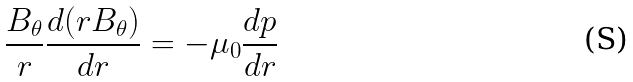Convert formula to latex. <formula><loc_0><loc_0><loc_500><loc_500>\frac { B _ { \theta } } { r } \frac { d ( r B _ { \theta } ) } { d r } = - \mu _ { 0 } \frac { d p } { d r }</formula> 